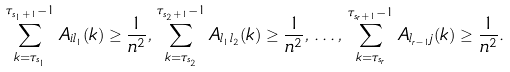Convert formula to latex. <formula><loc_0><loc_0><loc_500><loc_500>\sum _ { k = \tau _ { s _ { 1 } } } ^ { \tau _ { s _ { 1 } + 1 } - 1 } { A _ { i l _ { 1 } } ( k ) } \geq \frac { 1 } { n ^ { 2 } } , \, \sum _ { k = \tau _ { s _ { 2 } } } ^ { \tau _ { s _ { 2 } + 1 } - 1 } { A _ { l _ { 1 } l _ { 2 } } ( k ) } \geq \frac { 1 } { n ^ { 2 } } , \, \dots , \, \sum _ { k = \tau _ { s _ { r } } } ^ { \tau _ { s _ { r } + 1 } - 1 } { A _ { l _ { r - 1 } j } ( k ) } \geq \frac { 1 } { n ^ { 2 } } .</formula> 